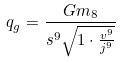Convert formula to latex. <formula><loc_0><loc_0><loc_500><loc_500>q _ { g } = \frac { G m _ { 8 } } { s ^ { 9 } \sqrt { 1 \cdot \frac { v ^ { 9 } } { j ^ { 9 } } } }</formula> 